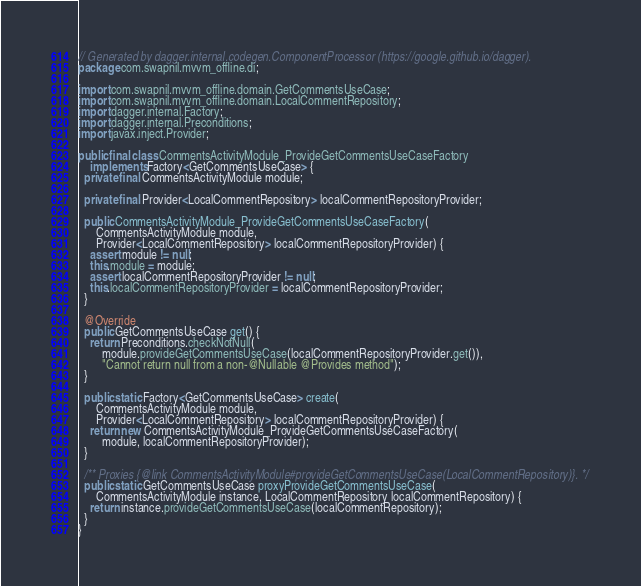Convert code to text. <code><loc_0><loc_0><loc_500><loc_500><_Java_>// Generated by dagger.internal.codegen.ComponentProcessor (https://google.github.io/dagger).
package com.swapnil.mvvm_offline.di;

import com.swapnil.mvvm_offline.domain.GetCommentsUseCase;
import com.swapnil.mvvm_offline.domain.LocalCommentRepository;
import dagger.internal.Factory;
import dagger.internal.Preconditions;
import javax.inject.Provider;

public final class CommentsActivityModule_ProvideGetCommentsUseCaseFactory
    implements Factory<GetCommentsUseCase> {
  private final CommentsActivityModule module;

  private final Provider<LocalCommentRepository> localCommentRepositoryProvider;

  public CommentsActivityModule_ProvideGetCommentsUseCaseFactory(
      CommentsActivityModule module,
      Provider<LocalCommentRepository> localCommentRepositoryProvider) {
    assert module != null;
    this.module = module;
    assert localCommentRepositoryProvider != null;
    this.localCommentRepositoryProvider = localCommentRepositoryProvider;
  }

  @Override
  public GetCommentsUseCase get() {
    return Preconditions.checkNotNull(
        module.provideGetCommentsUseCase(localCommentRepositoryProvider.get()),
        "Cannot return null from a non-@Nullable @Provides method");
  }

  public static Factory<GetCommentsUseCase> create(
      CommentsActivityModule module,
      Provider<LocalCommentRepository> localCommentRepositoryProvider) {
    return new CommentsActivityModule_ProvideGetCommentsUseCaseFactory(
        module, localCommentRepositoryProvider);
  }

  /** Proxies {@link CommentsActivityModule#provideGetCommentsUseCase(LocalCommentRepository)}. */
  public static GetCommentsUseCase proxyProvideGetCommentsUseCase(
      CommentsActivityModule instance, LocalCommentRepository localCommentRepository) {
    return instance.provideGetCommentsUseCase(localCommentRepository);
  }
}
</code> 